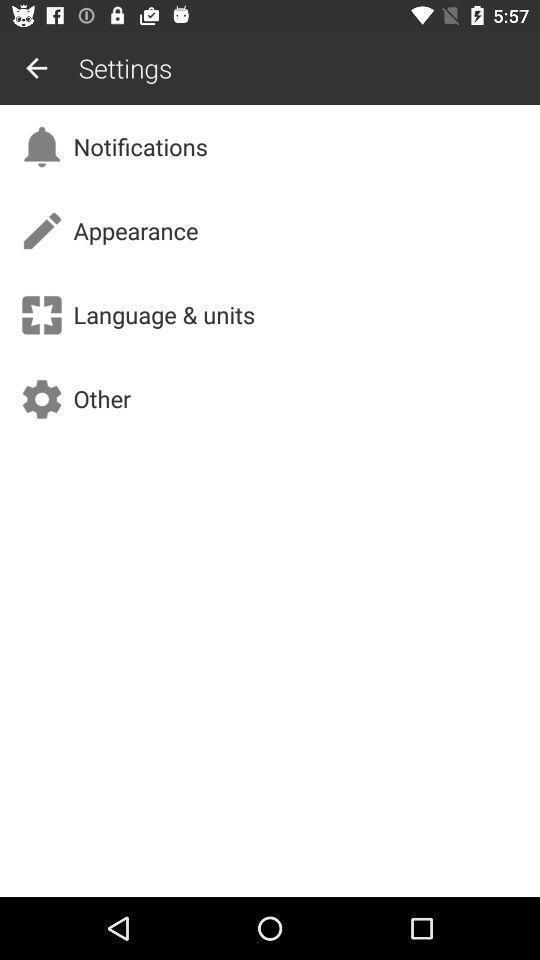Describe the content in this image. Settings page. 